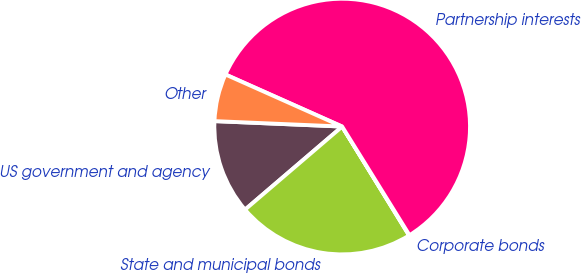<chart> <loc_0><loc_0><loc_500><loc_500><pie_chart><fcel>US government and agency<fcel>State and municipal bonds<fcel>Corporate bonds<fcel>Partnership interests<fcel>Other<nl><fcel>11.94%<fcel>22.51%<fcel>0.06%<fcel>59.49%<fcel>6.0%<nl></chart> 